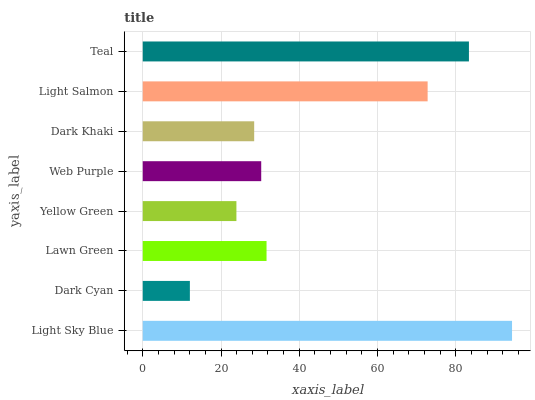Is Dark Cyan the minimum?
Answer yes or no. Yes. Is Light Sky Blue the maximum?
Answer yes or no. Yes. Is Lawn Green the minimum?
Answer yes or no. No. Is Lawn Green the maximum?
Answer yes or no. No. Is Lawn Green greater than Dark Cyan?
Answer yes or no. Yes. Is Dark Cyan less than Lawn Green?
Answer yes or no. Yes. Is Dark Cyan greater than Lawn Green?
Answer yes or no. No. Is Lawn Green less than Dark Cyan?
Answer yes or no. No. Is Lawn Green the high median?
Answer yes or no. Yes. Is Web Purple the low median?
Answer yes or no. Yes. Is Teal the high median?
Answer yes or no. No. Is Yellow Green the low median?
Answer yes or no. No. 